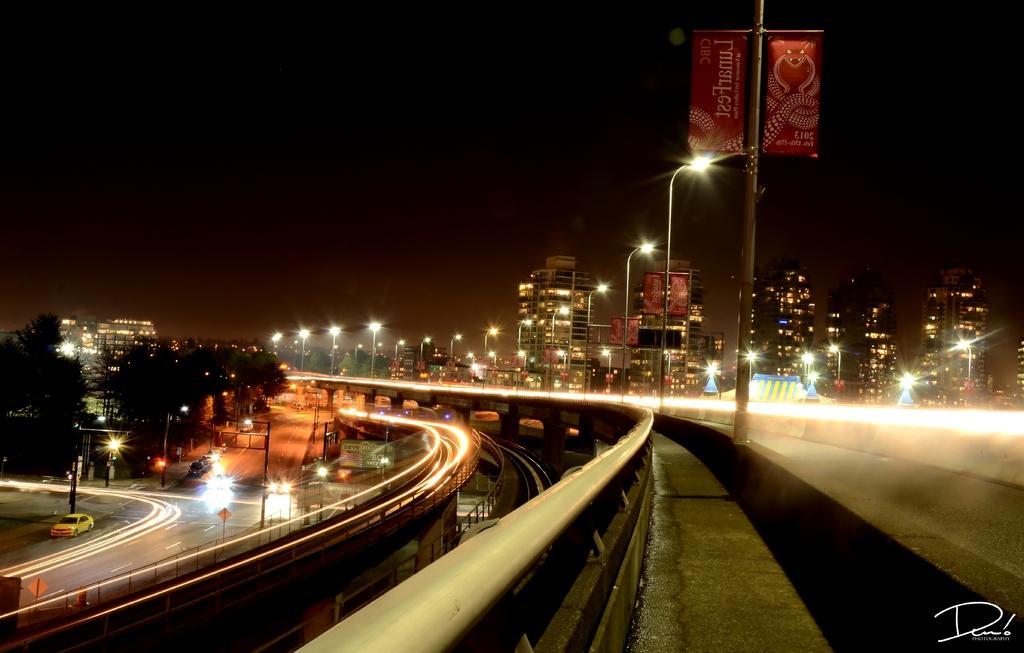Could you give a brief overview of what you see in this image? In this image we can see a cars travelling on the road, here is the light, here is the bridge, here is the street light, here are the trees, here are the buildings, here is the pole, at above here is the sky. 